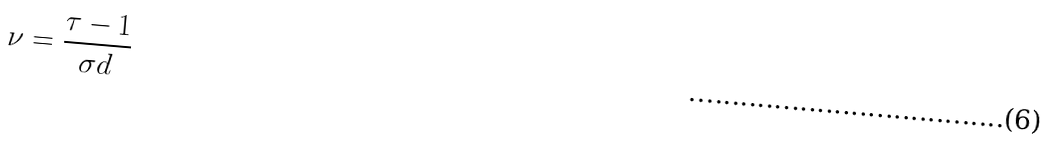Convert formula to latex. <formula><loc_0><loc_0><loc_500><loc_500>\nu = \frac { \tau - 1 } { \sigma d }</formula> 